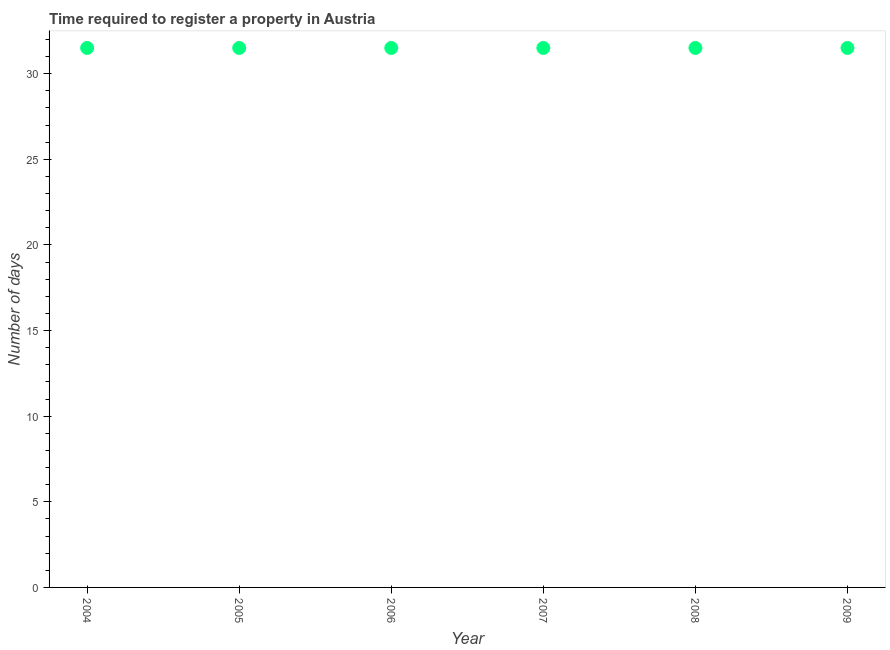What is the number of days required to register property in 2008?
Provide a short and direct response. 31.5. Across all years, what is the maximum number of days required to register property?
Offer a terse response. 31.5. Across all years, what is the minimum number of days required to register property?
Offer a very short reply. 31.5. In which year was the number of days required to register property maximum?
Give a very brief answer. 2004. What is the sum of the number of days required to register property?
Provide a short and direct response. 189. What is the average number of days required to register property per year?
Make the answer very short. 31.5. What is the median number of days required to register property?
Provide a short and direct response. 31.5. In how many years, is the number of days required to register property greater than 23 days?
Offer a terse response. 6. Do a majority of the years between 2007 and 2004 (inclusive) have number of days required to register property greater than 24 days?
Ensure brevity in your answer.  Yes. Is the number of days required to register property in 2005 less than that in 2007?
Provide a succinct answer. No. Is the difference between the number of days required to register property in 2005 and 2009 greater than the difference between any two years?
Make the answer very short. Yes. What is the difference between the highest and the second highest number of days required to register property?
Your response must be concise. 0. Is the sum of the number of days required to register property in 2005 and 2006 greater than the maximum number of days required to register property across all years?
Give a very brief answer. Yes. What is the difference between the highest and the lowest number of days required to register property?
Offer a terse response. 0. Does the number of days required to register property monotonically increase over the years?
Your answer should be compact. No. How many years are there in the graph?
Your response must be concise. 6. What is the difference between two consecutive major ticks on the Y-axis?
Your answer should be compact. 5. Are the values on the major ticks of Y-axis written in scientific E-notation?
Offer a very short reply. No. What is the title of the graph?
Make the answer very short. Time required to register a property in Austria. What is the label or title of the X-axis?
Your answer should be very brief. Year. What is the label or title of the Y-axis?
Provide a succinct answer. Number of days. What is the Number of days in 2004?
Provide a succinct answer. 31.5. What is the Number of days in 2005?
Your answer should be very brief. 31.5. What is the Number of days in 2006?
Keep it short and to the point. 31.5. What is the Number of days in 2007?
Offer a very short reply. 31.5. What is the Number of days in 2008?
Provide a short and direct response. 31.5. What is the Number of days in 2009?
Your response must be concise. 31.5. What is the difference between the Number of days in 2004 and 2006?
Make the answer very short. 0. What is the difference between the Number of days in 2004 and 2007?
Offer a terse response. 0. What is the difference between the Number of days in 2004 and 2008?
Provide a short and direct response. 0. What is the difference between the Number of days in 2005 and 2006?
Your response must be concise. 0. What is the difference between the Number of days in 2005 and 2007?
Keep it short and to the point. 0. What is the difference between the Number of days in 2006 and 2008?
Give a very brief answer. 0. What is the ratio of the Number of days in 2004 to that in 2005?
Your answer should be compact. 1. What is the ratio of the Number of days in 2004 to that in 2006?
Provide a succinct answer. 1. What is the ratio of the Number of days in 2005 to that in 2006?
Ensure brevity in your answer.  1. What is the ratio of the Number of days in 2005 to that in 2008?
Make the answer very short. 1. What is the ratio of the Number of days in 2007 to that in 2008?
Provide a succinct answer. 1. What is the ratio of the Number of days in 2008 to that in 2009?
Offer a very short reply. 1. 